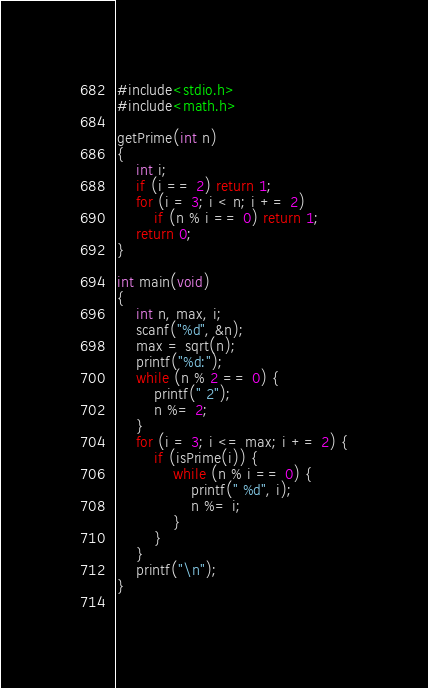Convert code to text. <code><loc_0><loc_0><loc_500><loc_500><_C_>#include<stdio.h>
#include<math.h>

getPrime(int n)
{
    int i;
    if (i == 2) return 1;
    for (i = 3; i < n; i += 2)
        if (n % i == 0) return 1;
    return 0;
}

int main(void)
{
    int n, max, i;
    scanf("%d", &n);
    max = sqrt(n);
    printf("%d:");
    while (n % 2 == 0) {
        printf(" 2");
        n %= 2;
    }
    for (i = 3; i <= max; i += 2) {
        if (isPrime(i)) {
            while (n % i == 0) {
                printf(" %d", i);
                n %= i;
            }
        }
    }
    printf("\n");
}
            

</code> 